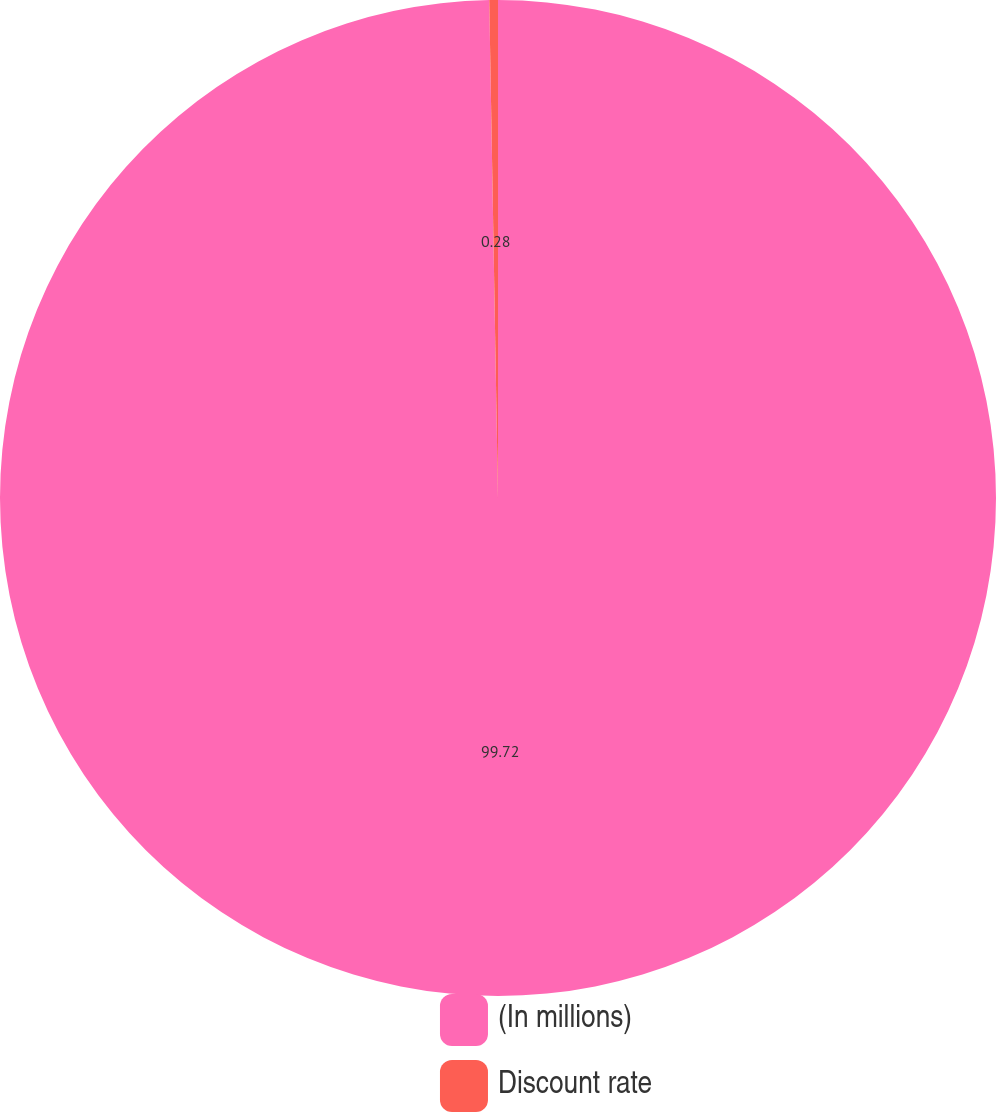Convert chart. <chart><loc_0><loc_0><loc_500><loc_500><pie_chart><fcel>(In millions)<fcel>Discount rate<nl><fcel>99.72%<fcel>0.28%<nl></chart> 